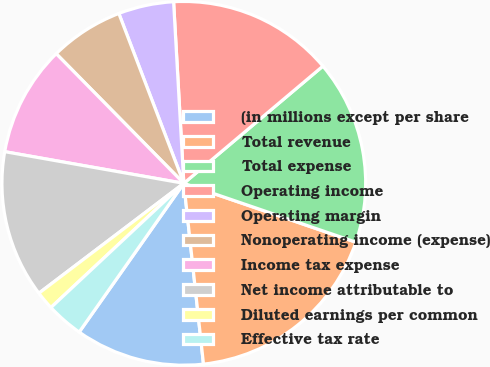<chart> <loc_0><loc_0><loc_500><loc_500><pie_chart><fcel>(in millions except per share<fcel>Total revenue<fcel>Total expense<fcel>Operating income<fcel>Operating margin<fcel>Nonoperating income (expense)<fcel>Income tax expense<fcel>Net income attributable to<fcel>Diluted earnings per common<fcel>Effective tax rate<nl><fcel>11.48%<fcel>18.03%<fcel>16.39%<fcel>14.75%<fcel>4.92%<fcel>6.56%<fcel>9.84%<fcel>13.11%<fcel>1.64%<fcel>3.28%<nl></chart> 